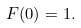<formula> <loc_0><loc_0><loc_500><loc_500>F ( 0 ) = 1 .</formula> 